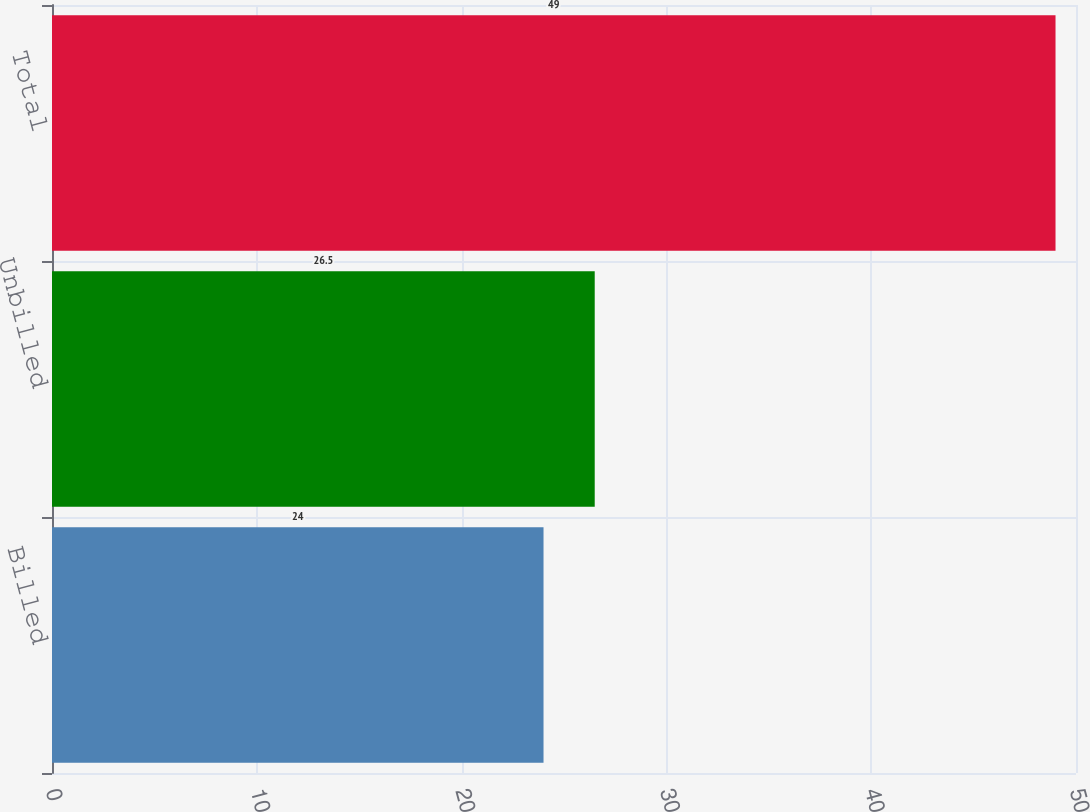<chart> <loc_0><loc_0><loc_500><loc_500><bar_chart><fcel>Billed<fcel>Unbilled<fcel>Total<nl><fcel>24<fcel>26.5<fcel>49<nl></chart> 